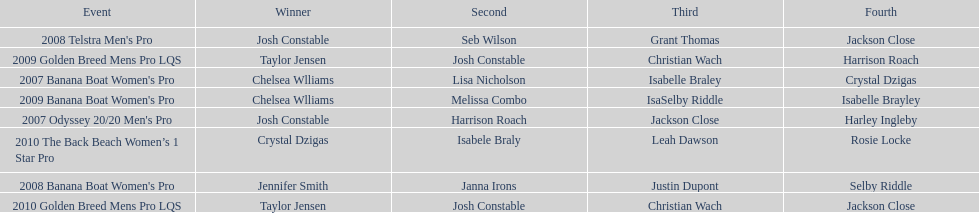How many times was josh constable second? 2. 